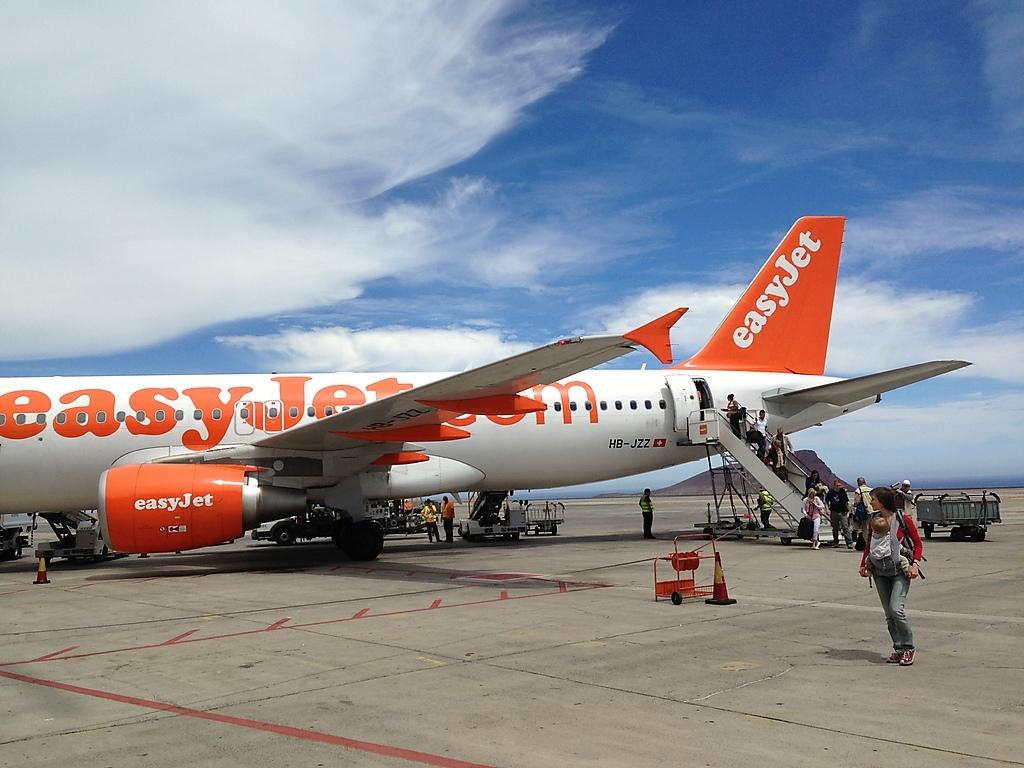<image>
Summarize the visual content of the image. EasyJet logo on a white and orange airplane 